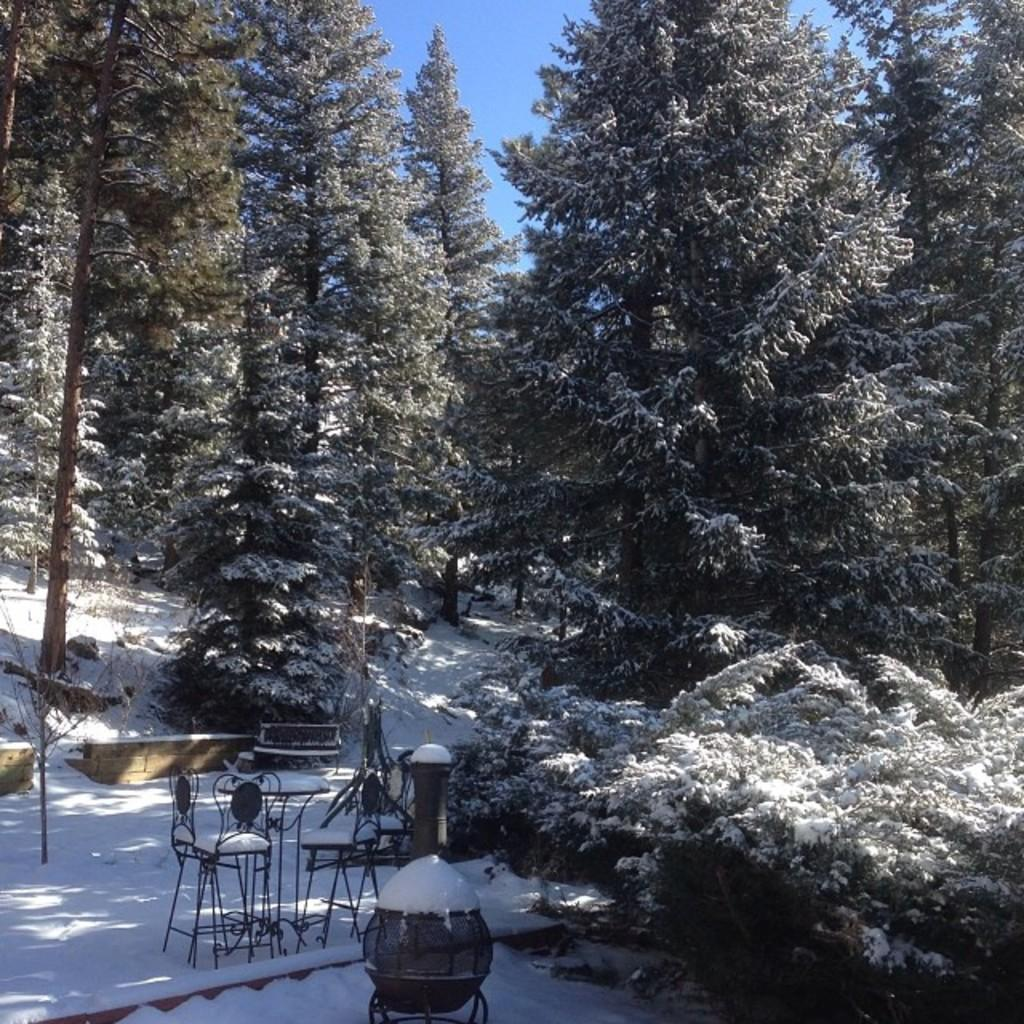What type of furniture is visible in the image? There are chairs and a table in the image. What is on top of the table in the image? Snow is present on the table. What type of natural environment is visible in the image? There are trees in the image. What is visible at the top of the image? The sky is visible at the top of the image. How many hands are visible holding the trees in the image? There are no hands visible holding the trees in the image. What type of adhesive is being used to attach the spiders to the chairs in the image? There are no spiders or adhesive present in the image. 